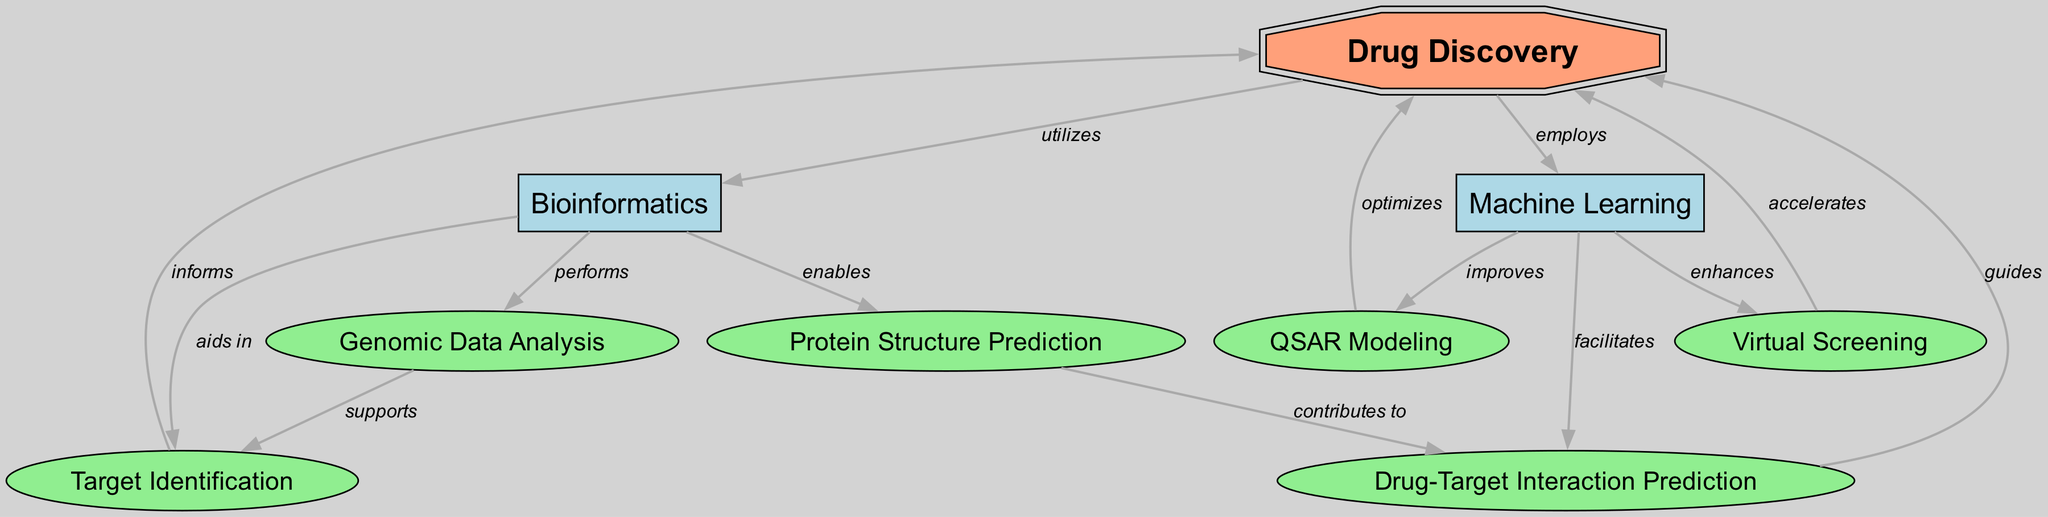What is the main focus of this concept map? The diagram revolves around the concept of Drug Discovery, which is represented as the central node. All other nodes and relationships connect to this main theme, outlining the integration of Bioinformatics and Machine Learning into Drug Discovery.
Answer: Drug Discovery How many nodes are present in the diagram? By counting the individual elements in the "nodes" section of the data, we find there are 9 nodes total related to various components and techniques in drug discovery.
Answer: 9 Which node indicates the use of Bioinformatics in drug discovery? The edge directly leading from the main node "Drug Discovery" to "Bioinformatics" indicates that Drug Discovery utilizes Bioinformatics as a crucial resource in the process.
Answer: Bioinformatics What relationship does Machine Learning have with Virtual Screening? By examining the edges, we see an arrow labeled "enhances" pointing from Machine Learning to Virtual Screening, indicating that Machine Learning plays an enhancing role in the Virtual Screening process.
Answer: enhances Which node performs genomic data analysis? In the diagram, the node labeled "Genomic Data Analysis" is directly connected to the Bioinformatics node, indicating that it is Bioinformatics that performs this analysis in the context of drug discovery.
Answer: Bioinformatics How does Protein Structure Prediction contribute to Drug-Target Interaction Prediction? The edge shows a connection from Protein Structure Prediction to Drug-Target Interaction Prediction, stating it "contributes to" it, which means the insights from predicting protein structures are instrumental in how drugs interact with their targets.
Answer: contributes to What kind of data does the "Target Identification" node support? The diagram shows a connection from the "Genomic Data Analysis" node to "Target Identification," indicating that the analysis of genomic data supports the target identification process essential in drug discovery.
Answer: supports What is the role of QSAR Modeling in Drug Discovery according to the map? According to the diagram, QSAR Modeling "optimizes" the Drug Discovery process, demonstrating its role in improving the efficacy and efficiency of developing drugs.
Answer: optimizes Which two fields are indicated to employ Drug Discovery? The diagram shows arrows labeled "utilizes" and "employs" pointing from Drug Discovery to both Bioinformatics and Machine Learning, respectively, indicating that both fields are applied in the Drug Discovery process.
Answer: Bioinformatics, Machine Learning What informs Target Identification? The relationship represented in the diagram indicates that Target Identification is informed by insights gained through the Drug Discovery process, as denoted by the edge labeled "informs" from Target Identification back to Drug Discovery.
Answer: informs 